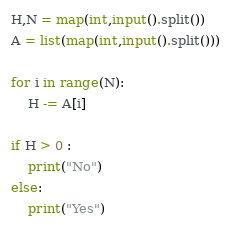Convert code to text. <code><loc_0><loc_0><loc_500><loc_500><_Python_>H,N = map(int,input().split())
A = list(map(int,input().split()))

for i in range(N):
    H -= A[i]

if H > 0 :
    print("No")
else:
    print("Yes")
</code> 